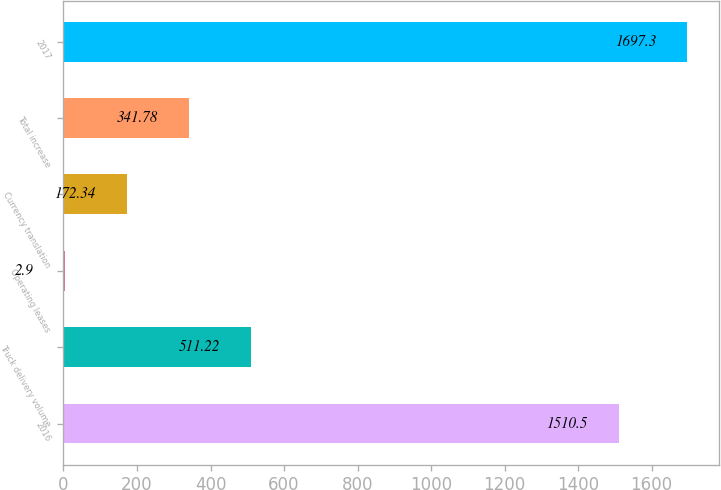<chart> <loc_0><loc_0><loc_500><loc_500><bar_chart><fcel>2016<fcel>Truck delivery volume<fcel>Operating leases<fcel>Currency translation<fcel>Total increase<fcel>2017<nl><fcel>1510.5<fcel>511.22<fcel>2.9<fcel>172.34<fcel>341.78<fcel>1697.3<nl></chart> 